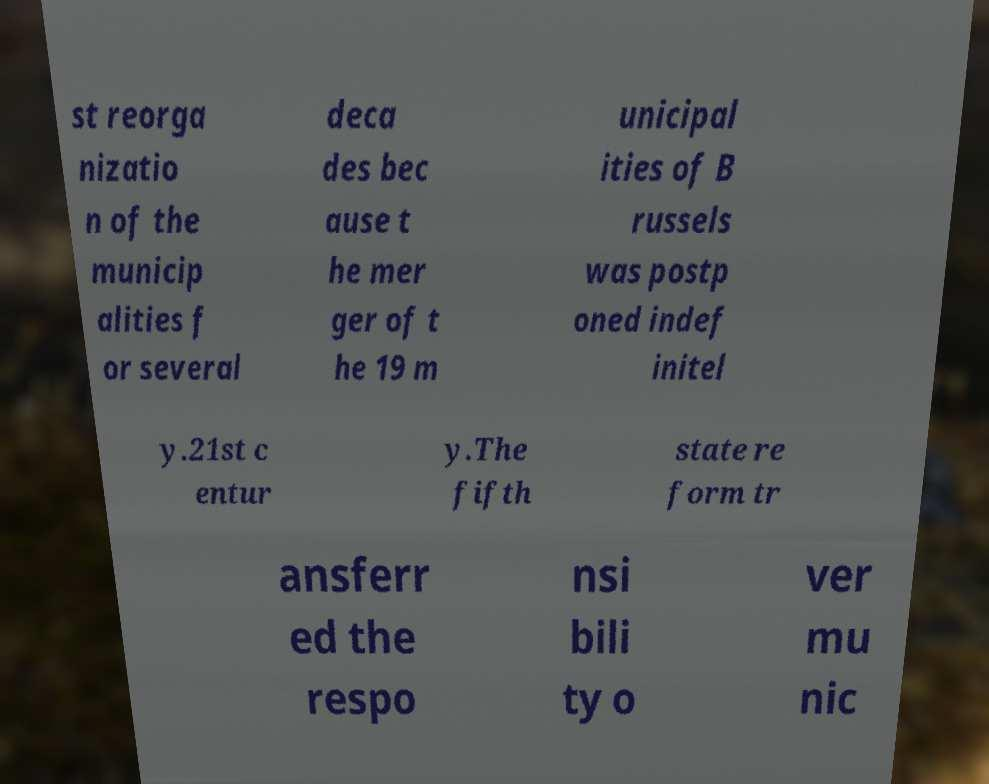Can you read and provide the text displayed in the image?This photo seems to have some interesting text. Can you extract and type it out for me? st reorga nizatio n of the municip alities f or several deca des bec ause t he mer ger of t he 19 m unicipal ities of B russels was postp oned indef initel y.21st c entur y.The fifth state re form tr ansferr ed the respo nsi bili ty o ver mu nic 